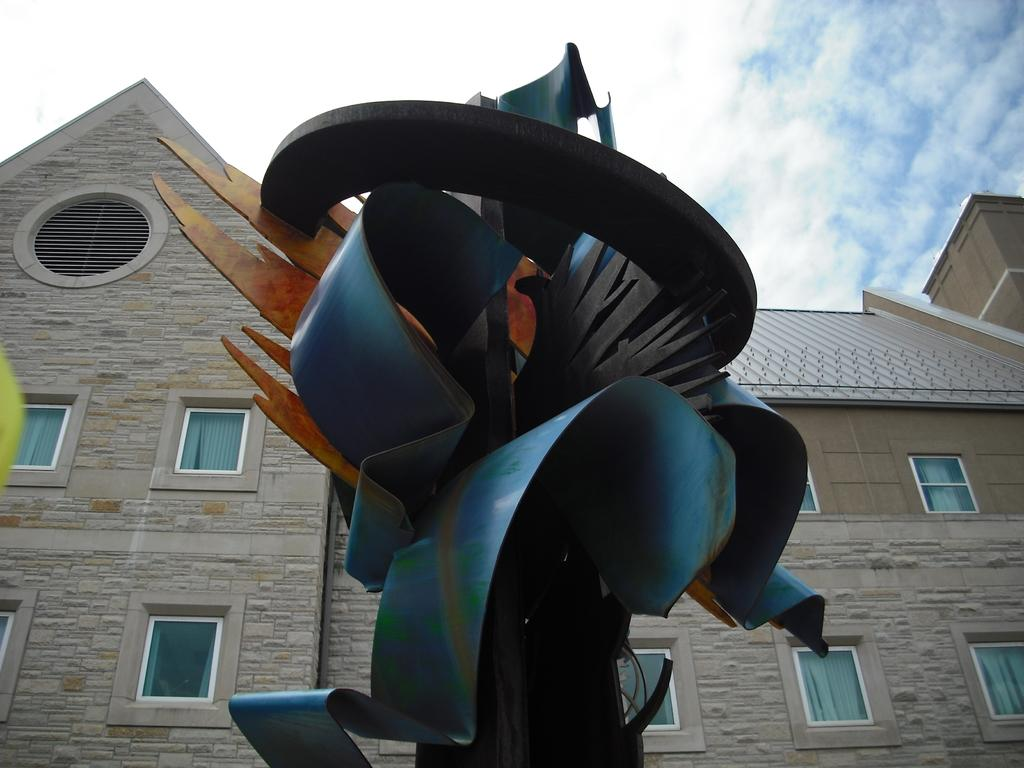What is the main subject in the image? There is a statue in the image. What can be seen in the background of the image? There is a building with a roof in the background of the image. What feature of the building is mentioned in the facts? The building has a group of windows. How would you describe the sky in the image? The sky is cloudy in the background of the image. What type of statement is being made by the statue in the image? The statue does not make a statement in the image; it is a sculpture and does not have the ability to communicate verbally. 